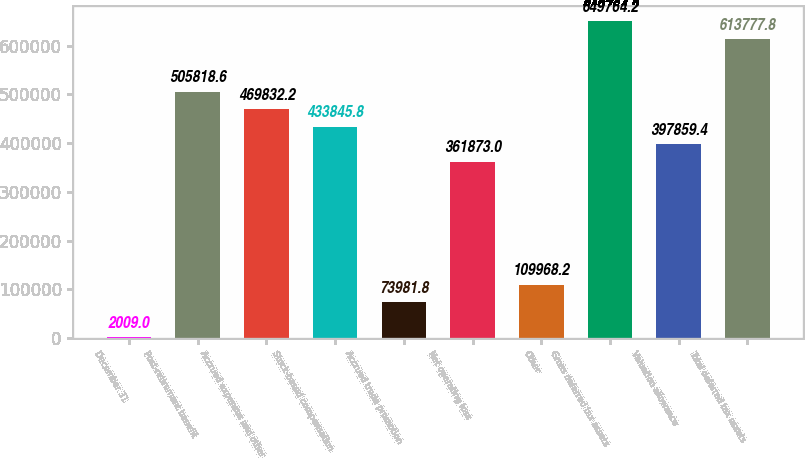<chart> <loc_0><loc_0><loc_500><loc_500><bar_chart><fcel>December 31<fcel>Post-retirement benefit<fcel>Accrued expenses and other<fcel>Stock-based compensation<fcel>Accrued trade promotion<fcel>Net operating loss<fcel>Other<fcel>Gross deferred tax assets<fcel>Valuation allowance<fcel>Total deferred tax assets<nl><fcel>2009<fcel>505819<fcel>469832<fcel>433846<fcel>73981.8<fcel>361873<fcel>109968<fcel>649764<fcel>397859<fcel>613778<nl></chart> 